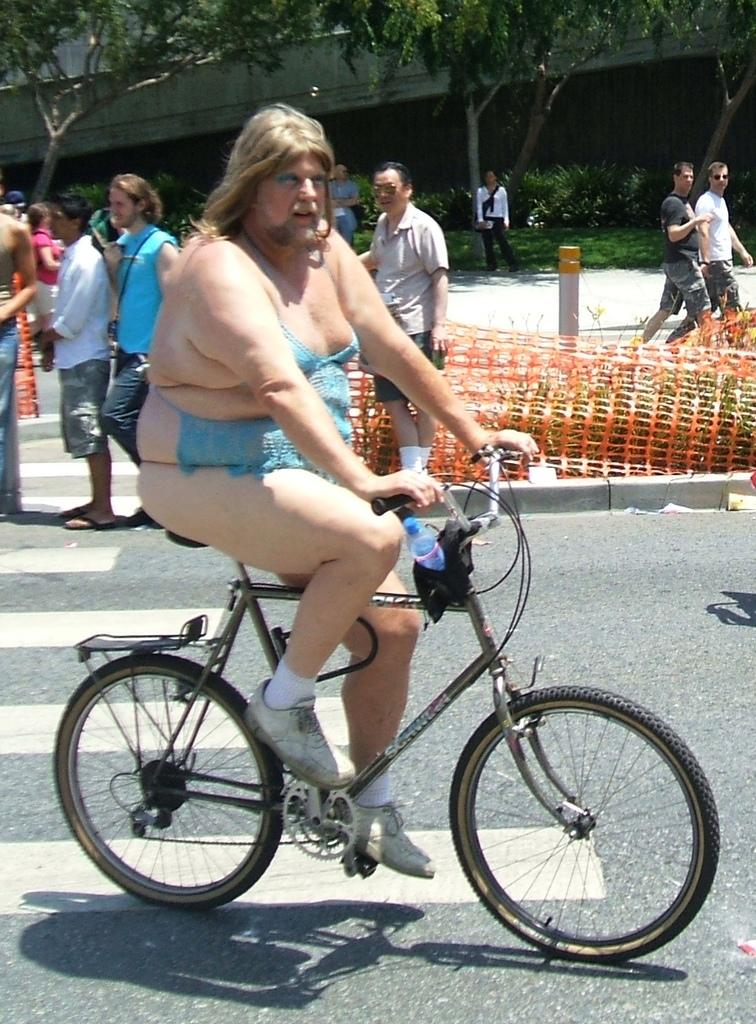What is the man in the image wearing? The man is wearing a women's dress. What is the man doing in the image? The man is riding a cycle. Where is the scene taking place? The scene takes place on a road. What else can be seen on the road besides the man on the cycle? There are people walking on the road. What type of vegetation is present in the scene? There are trees in the middle of the scene. How does the man express his feeling of rest while riding the cycle? There is no indication in the image that the man is expressing any feelings of rest, as the focus is on his attire and activity. 